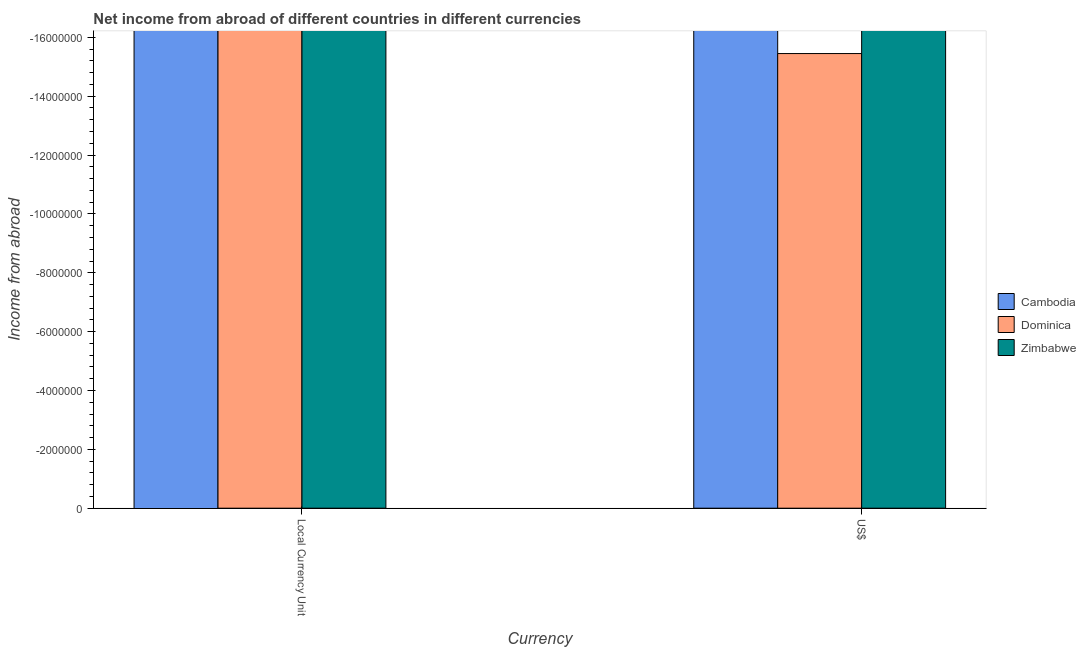How many different coloured bars are there?
Give a very brief answer. 0. Are the number of bars per tick equal to the number of legend labels?
Offer a terse response. No. Are the number of bars on each tick of the X-axis equal?
Your answer should be compact. Yes. What is the label of the 1st group of bars from the left?
Make the answer very short. Local Currency Unit. Across all countries, what is the minimum income from abroad in constant 2005 us$?
Your answer should be very brief. 0. What is the difference between the income from abroad in constant 2005 us$ in Cambodia and the income from abroad in us$ in Dominica?
Make the answer very short. 0. How many bars are there?
Your response must be concise. 0. Are all the bars in the graph horizontal?
Give a very brief answer. No. How many countries are there in the graph?
Offer a terse response. 3. Are the values on the major ticks of Y-axis written in scientific E-notation?
Offer a terse response. No. How many legend labels are there?
Give a very brief answer. 3. What is the title of the graph?
Give a very brief answer. Net income from abroad of different countries in different currencies. Does "Mauritius" appear as one of the legend labels in the graph?
Give a very brief answer. No. What is the label or title of the X-axis?
Ensure brevity in your answer.  Currency. What is the label or title of the Y-axis?
Provide a short and direct response. Income from abroad. What is the Income from abroad in Cambodia in Local Currency Unit?
Make the answer very short. 0. What is the Income from abroad of Dominica in Local Currency Unit?
Provide a short and direct response. 0. What is the total Income from abroad of Cambodia in the graph?
Your answer should be compact. 0. What is the total Income from abroad of Zimbabwe in the graph?
Your answer should be very brief. 0. What is the average Income from abroad of Cambodia per Currency?
Ensure brevity in your answer.  0. What is the average Income from abroad of Zimbabwe per Currency?
Offer a terse response. 0. 